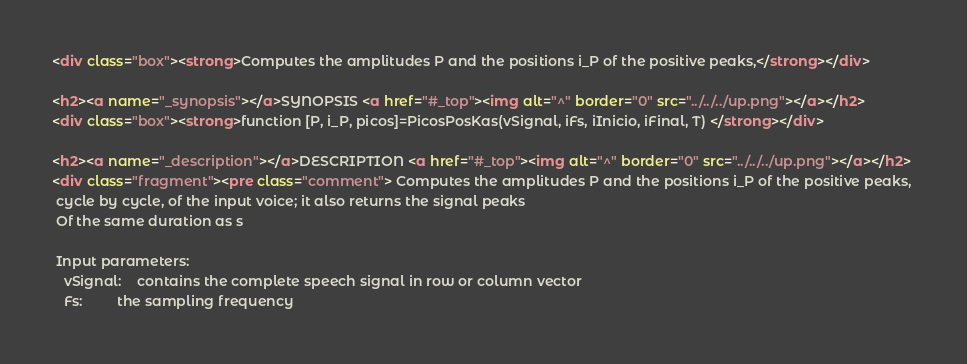Convert code to text. <code><loc_0><loc_0><loc_500><loc_500><_HTML_><div class="box"><strong>Computes the amplitudes P and the positions i_P of the positive peaks,</strong></div>

<h2><a name="_synopsis"></a>SYNOPSIS <a href="#_top"><img alt="^" border="0" src="../../../up.png"></a></h2>
<div class="box"><strong>function [P, i_P, picos]=PicosPosKas(vSignal, iFs, iInicio, iFinal, T) </strong></div>

<h2><a name="_description"></a>DESCRIPTION <a href="#_top"><img alt="^" border="0" src="../../../up.png"></a></h2>
<div class="fragment"><pre class="comment"> Computes the amplitudes P and the positions i_P of the positive peaks, 
 cycle by cycle, of the input voice; it also returns the signal peaks 
 Of the same duration as s

 Input parameters:
   vSignal:    contains the complete speech signal in row or column vector
   Fs:         the sampling frequency</code> 